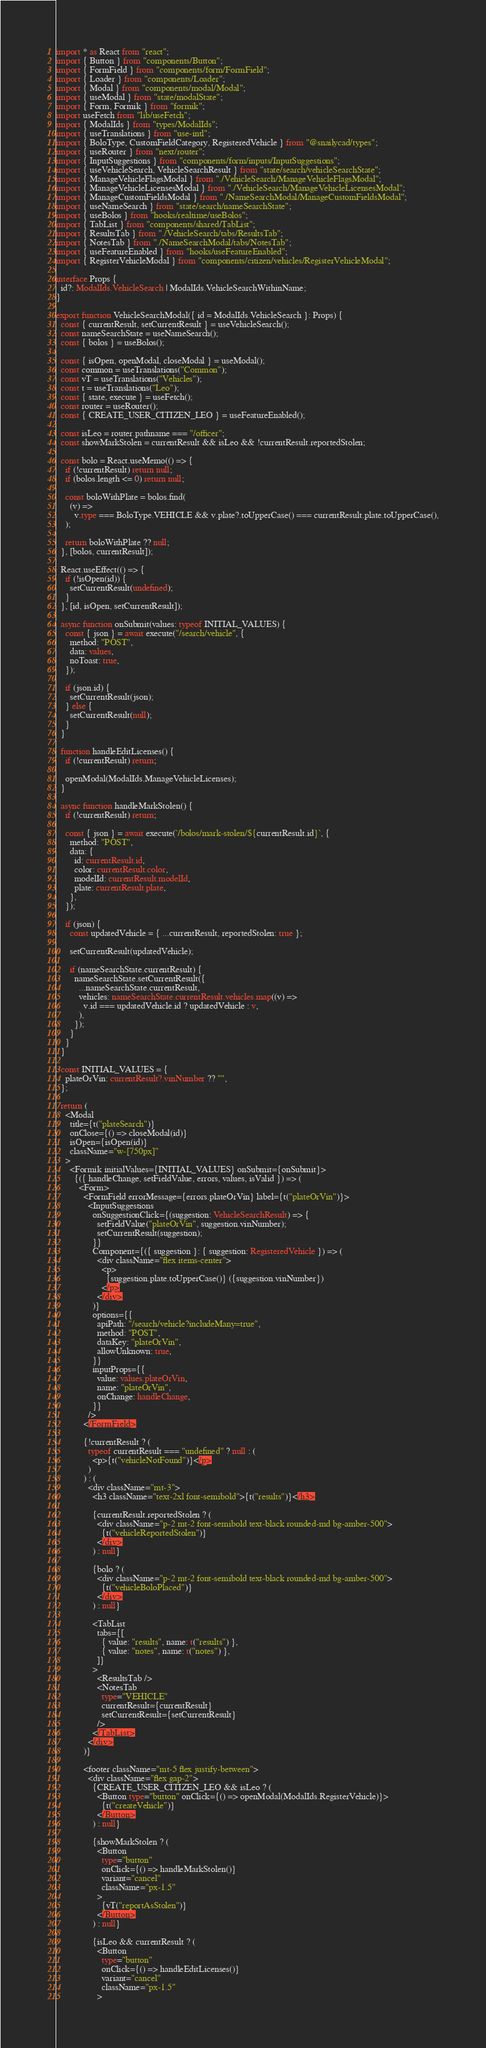Convert code to text. <code><loc_0><loc_0><loc_500><loc_500><_TypeScript_>import * as React from "react";
import { Button } from "components/Button";
import { FormField } from "components/form/FormField";
import { Loader } from "components/Loader";
import { Modal } from "components/modal/Modal";
import { useModal } from "state/modalState";
import { Form, Formik } from "formik";
import useFetch from "lib/useFetch";
import { ModalIds } from "types/ModalIds";
import { useTranslations } from "use-intl";
import { BoloType, CustomFieldCategory, RegisteredVehicle } from "@snailycad/types";
import { useRouter } from "next/router";
import { InputSuggestions } from "components/form/inputs/InputSuggestions";
import { useVehicleSearch, VehicleSearchResult } from "state/search/vehicleSearchState";
import { ManageVehicleFlagsModal } from "./VehicleSearch/ManageVehicleFlagsModal";
import { ManageVehicleLicensesModal } from "./VehicleSearch/ManageVehicleLicensesModal";
import { ManageCustomFieldsModal } from "./NameSearchModal/ManageCustomFieldsModal";
import { useNameSearch } from "state/search/nameSearchState";
import { useBolos } from "hooks/realtime/useBolos";
import { TabList } from "components/shared/TabList";
import { ResultsTab } from "./VehicleSearch/tabs/ResultsTab";
import { NotesTab } from "./NameSearchModal/tabs/NotesTab";
import { useFeatureEnabled } from "hooks/useFeatureEnabled";
import { RegisterVehicleModal } from "components/citizen/vehicles/RegisterVehicleModal";

interface Props {
  id?: ModalIds.VehicleSearch | ModalIds.VehicleSearchWithinName;
}

export function VehicleSearchModal({ id = ModalIds.VehicleSearch }: Props) {
  const { currentResult, setCurrentResult } = useVehicleSearch();
  const nameSearchState = useNameSearch();
  const { bolos } = useBolos();

  const { isOpen, openModal, closeModal } = useModal();
  const common = useTranslations("Common");
  const vT = useTranslations("Vehicles");
  const t = useTranslations("Leo");
  const { state, execute } = useFetch();
  const router = useRouter();
  const { CREATE_USER_CITIZEN_LEO } = useFeatureEnabled();

  const isLeo = router.pathname === "/officer";
  const showMarkStolen = currentResult && isLeo && !currentResult.reportedStolen;

  const bolo = React.useMemo(() => {
    if (!currentResult) return null;
    if (bolos.length <= 0) return null;

    const boloWithPlate = bolos.find(
      (v) =>
        v.type === BoloType.VEHICLE && v.plate?.toUpperCase() === currentResult.plate.toUpperCase(),
    );

    return boloWithPlate ?? null;
  }, [bolos, currentResult]);

  React.useEffect(() => {
    if (!isOpen(id)) {
      setCurrentResult(undefined);
    }
  }, [id, isOpen, setCurrentResult]);

  async function onSubmit(values: typeof INITIAL_VALUES) {
    const { json } = await execute("/search/vehicle", {
      method: "POST",
      data: values,
      noToast: true,
    });

    if (json.id) {
      setCurrentResult(json);
    } else {
      setCurrentResult(null);
    }
  }

  function handleEditLicenses() {
    if (!currentResult) return;

    openModal(ModalIds.ManageVehicleLicenses);
  }

  async function handleMarkStolen() {
    if (!currentResult) return;

    const { json } = await execute(`/bolos/mark-stolen/${currentResult.id}`, {
      method: "POST",
      data: {
        id: currentResult.id,
        color: currentResult.color,
        modelId: currentResult.modelId,
        plate: currentResult.plate,
      },
    });

    if (json) {
      const updatedVehicle = { ...currentResult, reportedStolen: true };

      setCurrentResult(updatedVehicle);

      if (nameSearchState.currentResult) {
        nameSearchState.setCurrentResult({
          ...nameSearchState.currentResult,
          vehicles: nameSearchState.currentResult.vehicles.map((v) =>
            v.id === updatedVehicle.id ? updatedVehicle : v,
          ),
        });
      }
    }
  }

  const INITIAL_VALUES = {
    plateOrVin: currentResult?.vinNumber ?? "",
  };

  return (
    <Modal
      title={t("plateSearch")}
      onClose={() => closeModal(id)}
      isOpen={isOpen(id)}
      className="w-[750px]"
    >
      <Formik initialValues={INITIAL_VALUES} onSubmit={onSubmit}>
        {({ handleChange, setFieldValue, errors, values, isValid }) => (
          <Form>
            <FormField errorMessage={errors.plateOrVin} label={t("plateOrVin")}>
              <InputSuggestions
                onSuggestionClick={(suggestion: VehicleSearchResult) => {
                  setFieldValue("plateOrVin", suggestion.vinNumber);
                  setCurrentResult(suggestion);
                }}
                Component={({ suggestion }: { suggestion: RegisteredVehicle }) => (
                  <div className="flex items-center">
                    <p>
                      {suggestion.plate.toUpperCase()} ({suggestion.vinNumber})
                    </p>
                  </div>
                )}
                options={{
                  apiPath: "/search/vehicle?includeMany=true",
                  method: "POST",
                  dataKey: "plateOrVin",
                  allowUnknown: true,
                }}
                inputProps={{
                  value: values.plateOrVin,
                  name: "plateOrVin",
                  onChange: handleChange,
                }}
              />
            </FormField>

            {!currentResult ? (
              typeof currentResult === "undefined" ? null : (
                <p>{t("vehicleNotFound")}</p>
              )
            ) : (
              <div className="mt-3">
                <h3 className="text-2xl font-semibold">{t("results")}</h3>

                {currentResult.reportedStolen ? (
                  <div className="p-2 mt-2 font-semibold text-black rounded-md bg-amber-500">
                    {t("vehicleReportedStolen")}
                  </div>
                ) : null}

                {bolo ? (
                  <div className="p-2 mt-2 font-semibold text-black rounded-md bg-amber-500">
                    {t("vehicleBoloPlaced")}
                  </div>
                ) : null}

                <TabList
                  tabs={[
                    { value: "results", name: t("results") },
                    { value: "notes", name: t("notes") },
                  ]}
                >
                  <ResultsTab />
                  <NotesTab
                    type="VEHICLE"
                    currentResult={currentResult}
                    setCurrentResult={setCurrentResult}
                  />
                </TabList>
              </div>
            )}

            <footer className="mt-5 flex justify-between">
              <div className="flex gap-2">
                {CREATE_USER_CITIZEN_LEO && isLeo ? (
                  <Button type="button" onClick={() => openModal(ModalIds.RegisterVehicle)}>
                    {t("createVehicle")}
                  </Button>
                ) : null}

                {showMarkStolen ? (
                  <Button
                    type="button"
                    onClick={() => handleMarkStolen()}
                    variant="cancel"
                    className="px-1.5"
                  >
                    {vT("reportAsStolen")}
                  </Button>
                ) : null}

                {isLeo && currentResult ? (
                  <Button
                    type="button"
                    onClick={() => handleEditLicenses()}
                    variant="cancel"
                    className="px-1.5"
                  ></code> 